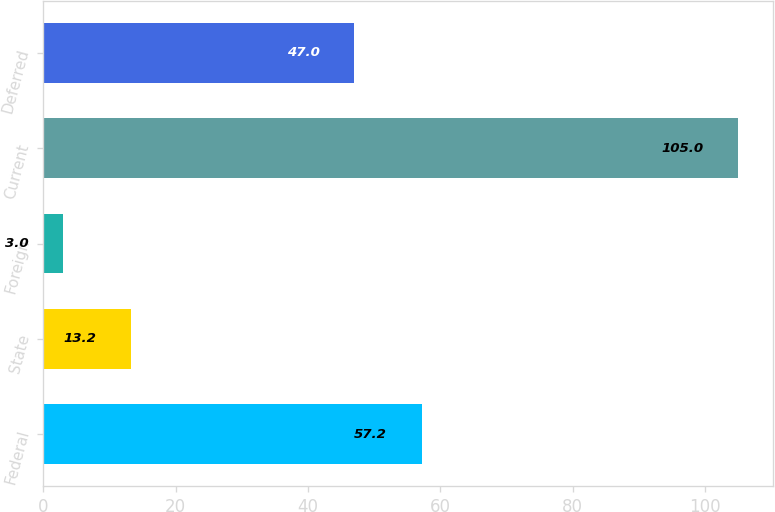Convert chart. <chart><loc_0><loc_0><loc_500><loc_500><bar_chart><fcel>Federal<fcel>State<fcel>Foreign<fcel>Current<fcel>Deferred<nl><fcel>57.2<fcel>13.2<fcel>3<fcel>105<fcel>47<nl></chart> 